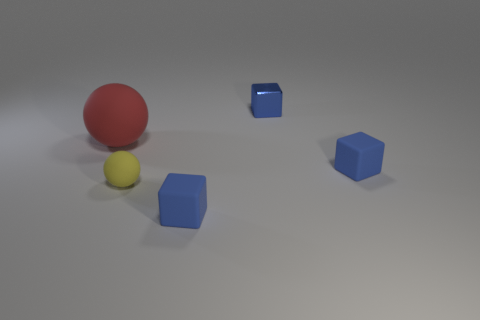Subtract all blue blocks. How many were subtracted if there are1blue blocks left? 2 Subtract all tiny matte cubes. How many cubes are left? 1 Add 4 tiny blue rubber spheres. How many objects exist? 9 Subtract all balls. How many objects are left? 3 Subtract all yellow balls. How many balls are left? 1 Subtract all green spheres. Subtract all gray blocks. How many spheres are left? 2 Subtract all cyan cylinders. How many red balls are left? 1 Subtract all metallic blocks. Subtract all small yellow matte objects. How many objects are left? 3 Add 5 red matte balls. How many red matte balls are left? 6 Add 1 large blue shiny spheres. How many large blue shiny spheres exist? 1 